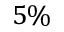<formula> <loc_0><loc_0><loc_500><loc_500>5 \%</formula> 